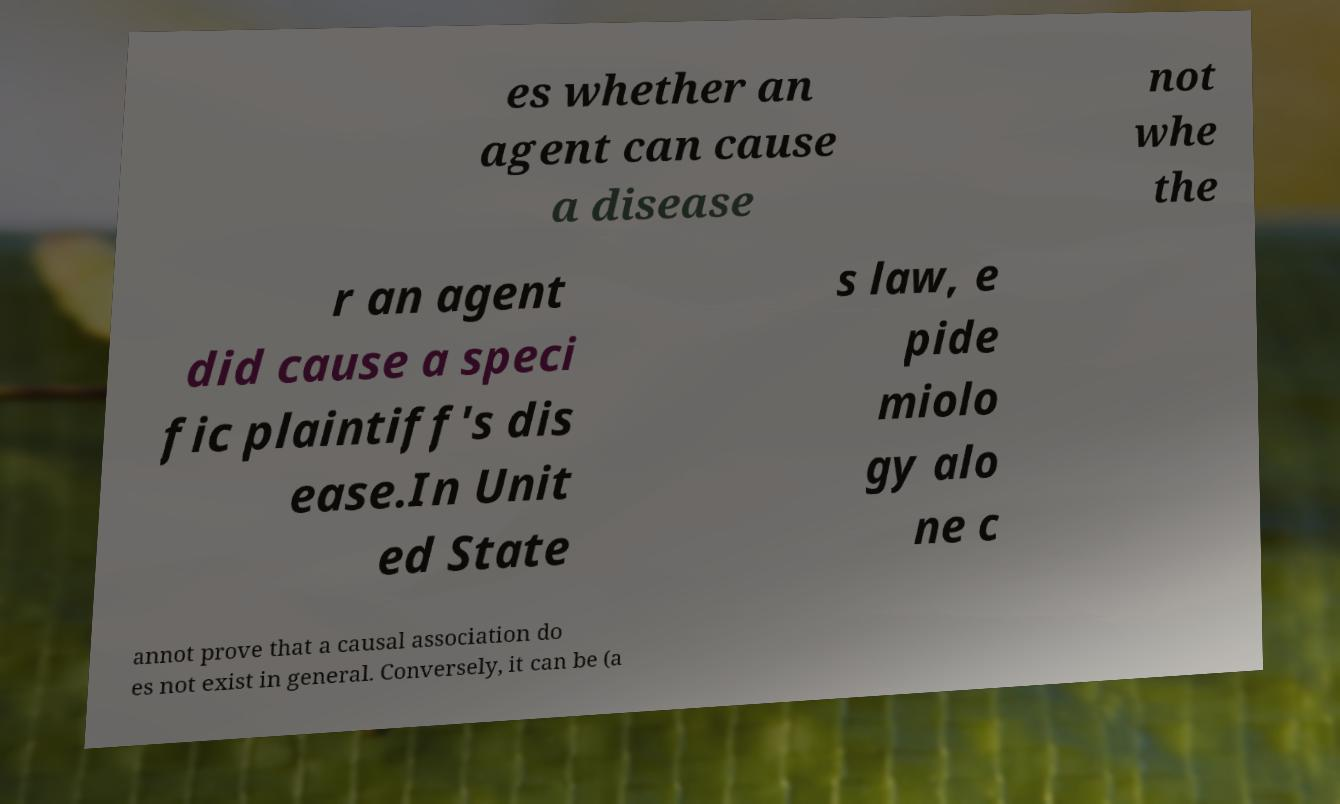I need the written content from this picture converted into text. Can you do that? es whether an agent can cause a disease not whe the r an agent did cause a speci fic plaintiff's dis ease.In Unit ed State s law, e pide miolo gy alo ne c annot prove that a causal association do es not exist in general. Conversely, it can be (a 